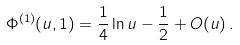<formula> <loc_0><loc_0><loc_500><loc_500>\Phi ^ { ( 1 ) } ( u , 1 ) = \frac { 1 } { 4 } \ln u - \frac { 1 } { 2 } + O ( u ) \, .</formula> 